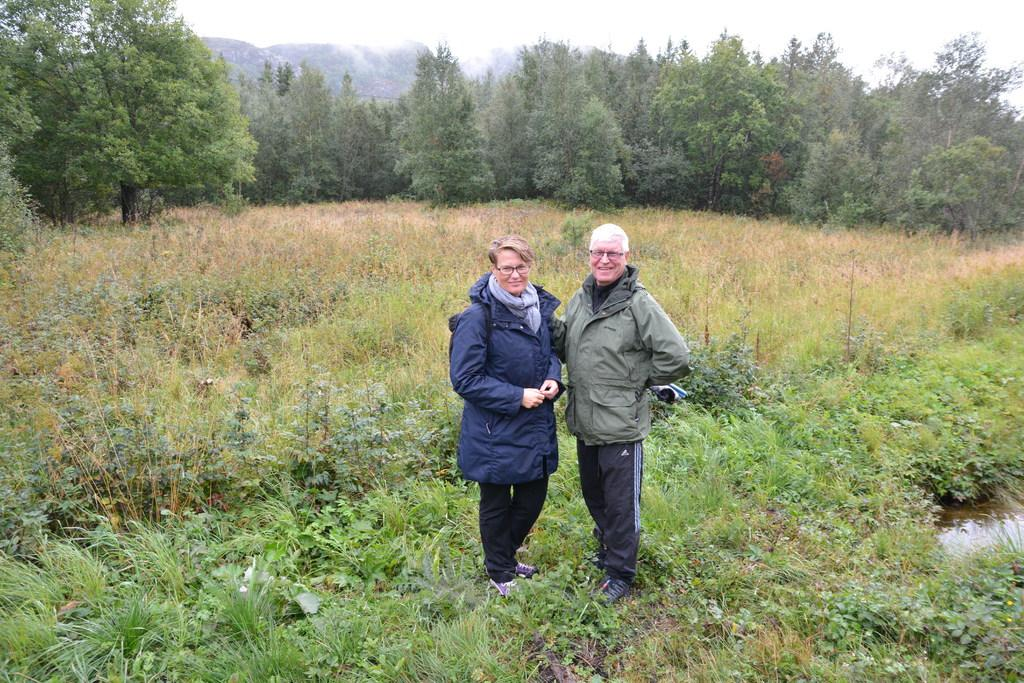Who are the people in the image? There is an old woman and an old man in the image. What is the old man wearing? The old man is wearing a jacket. Where does the scene take place? The scene takes place on grassland. What can be seen in the background of the image? There are plants in the background. What is visible in the sky in the image? The sky is visible in the image. What type of coach can be seen in the image? There is no coach present in the image. How many cattle are visible in the scene? There are no cattle visible in the image; the scene takes place on grassland with plants in the background. 